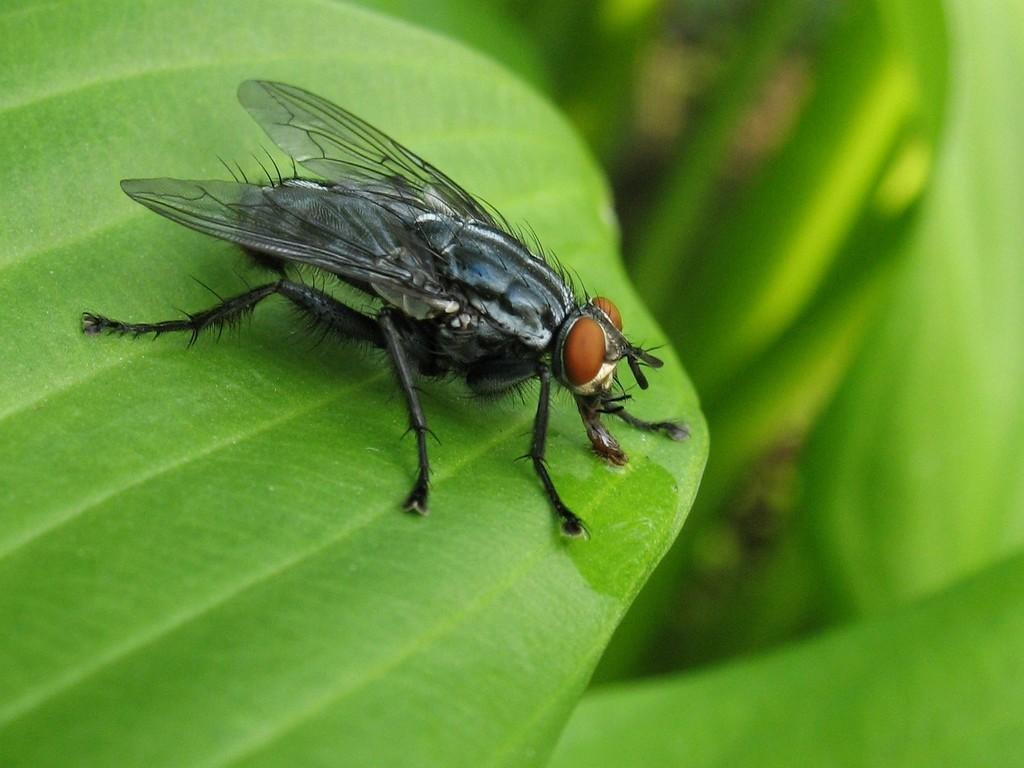What is the main subject of the image? There is an insect on a leaf in the image. Can you describe the background of the image? The background of the image is blurred. What type of idea is being discussed by the insect in the image? There is no indication in the image that the insect is discussing any ideas. What color is the curtain in the image? There is no curtain present in the image. 